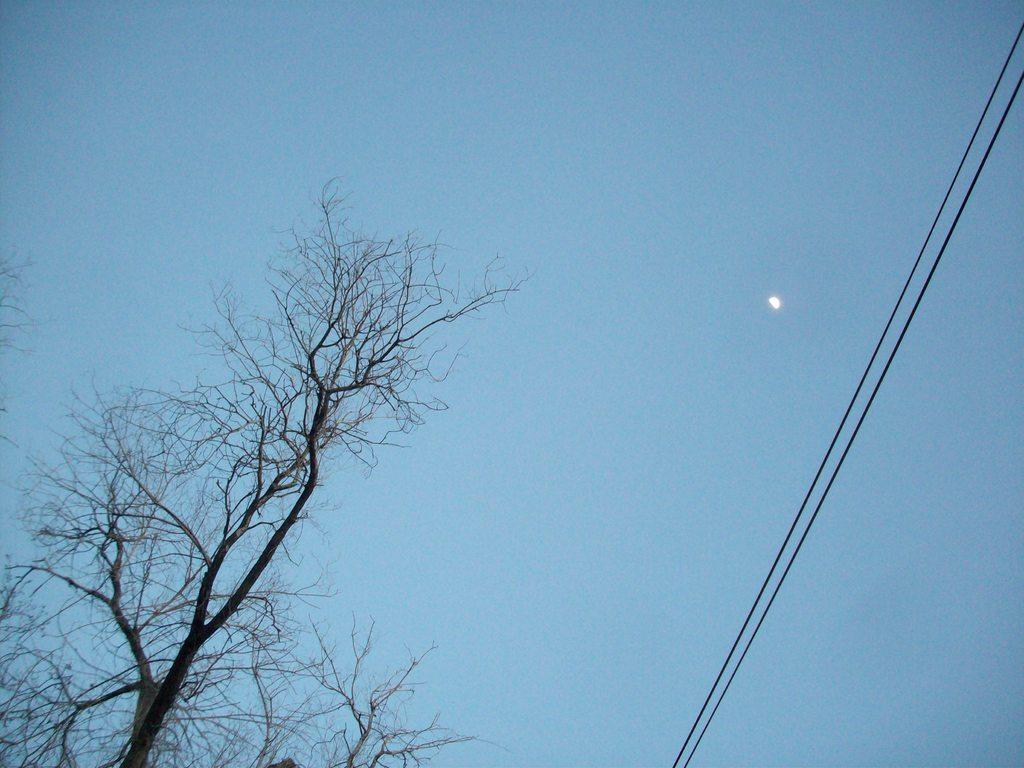Describe this image in one or two sentences. In the image we can see tree branches, electric wires, half moon and a pale blue color sky. 